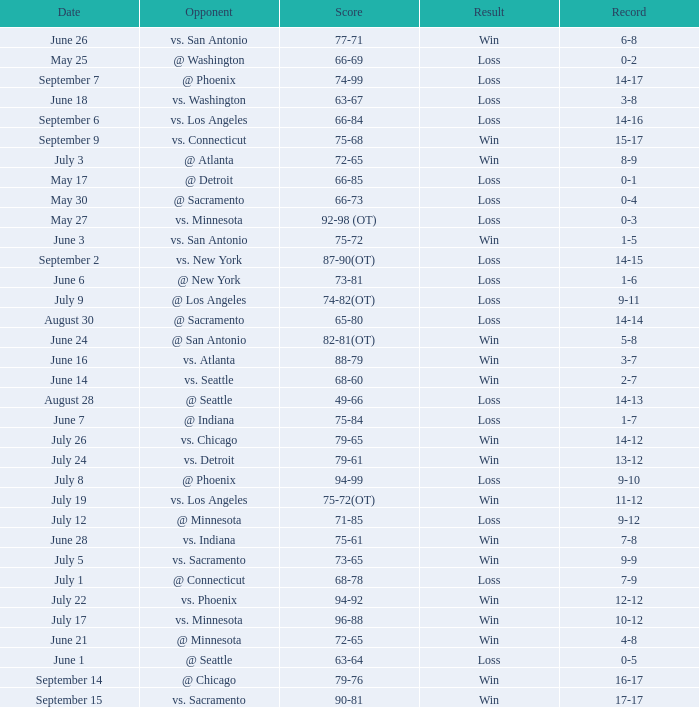What was the Result on May 30? Loss. 